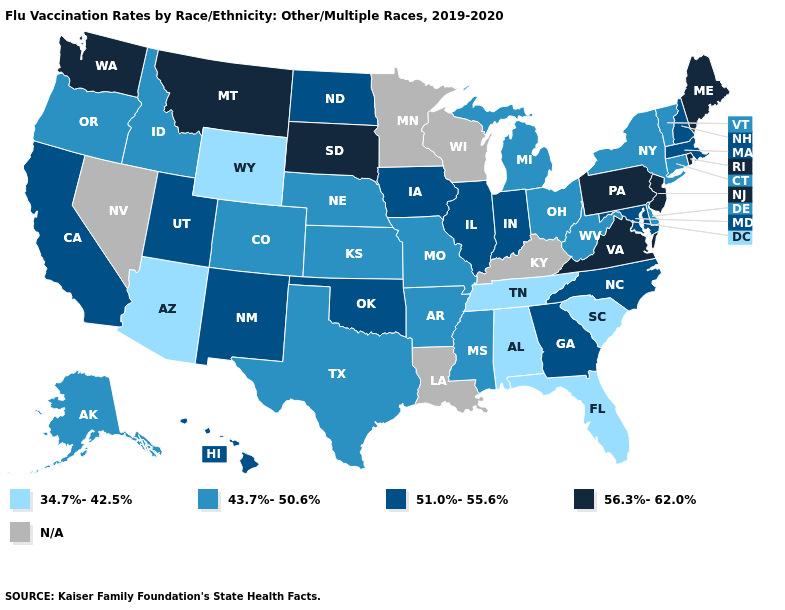What is the highest value in states that border Ohio?
Give a very brief answer. 56.3%-62.0%. Does Washington have the highest value in the USA?
Give a very brief answer. Yes. What is the lowest value in the Northeast?
Quick response, please. 43.7%-50.6%. Name the states that have a value in the range 34.7%-42.5%?
Give a very brief answer. Alabama, Arizona, Florida, South Carolina, Tennessee, Wyoming. What is the lowest value in the USA?
Be succinct. 34.7%-42.5%. What is the value of Vermont?
Short answer required. 43.7%-50.6%. Name the states that have a value in the range 43.7%-50.6%?
Answer briefly. Alaska, Arkansas, Colorado, Connecticut, Delaware, Idaho, Kansas, Michigan, Mississippi, Missouri, Nebraska, New York, Ohio, Oregon, Texas, Vermont, West Virginia. What is the highest value in the South ?
Be succinct. 56.3%-62.0%. Does Arizona have the lowest value in the USA?
Concise answer only. Yes. How many symbols are there in the legend?
Be succinct. 5. Among the states that border Louisiana , which have the highest value?
Short answer required. Arkansas, Mississippi, Texas. Does Virginia have the highest value in the South?
Answer briefly. Yes. Name the states that have a value in the range N/A?
Quick response, please. Kentucky, Louisiana, Minnesota, Nevada, Wisconsin. 